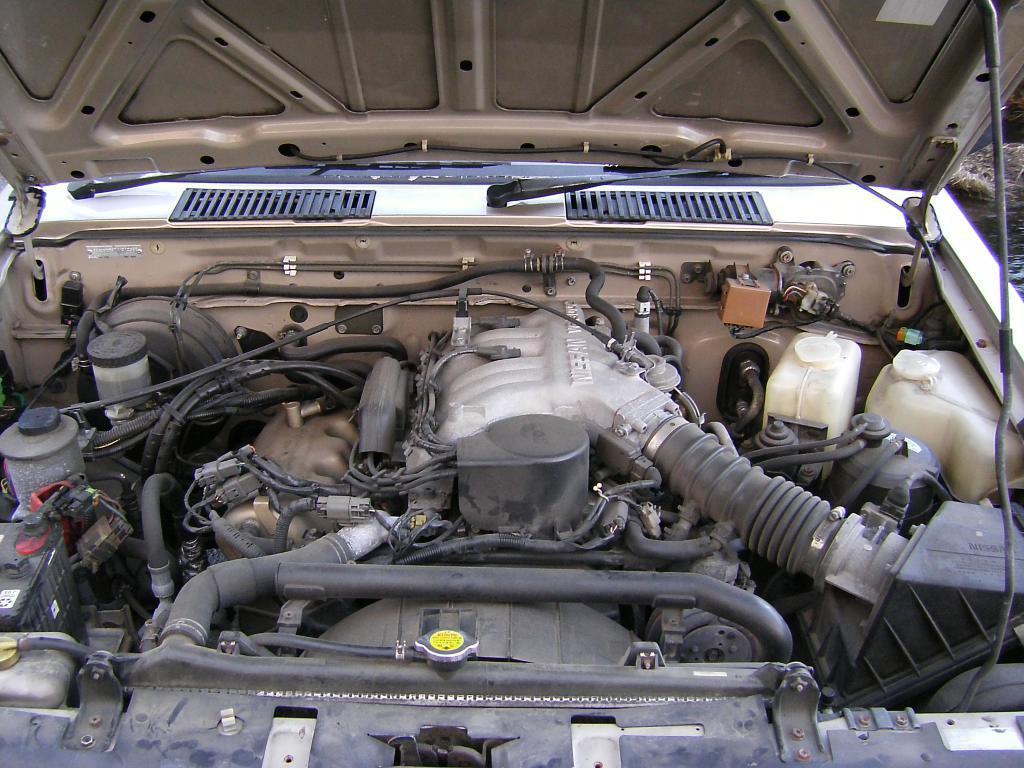What type of object is the main subject of the image? The main subject of the image is a vehicle. Can you describe any specific parts of the vehicle that are visible in the image? Yes, there are parts of the vehicle visible in the image. What type of components can be seen inside the vehicle? There are wires and bolts visible inside the vehicle. How many goldfish are swimming in the office depicted in the image? There is no office or goldfish present in the image; it features a vehicle with wires and bolts. 